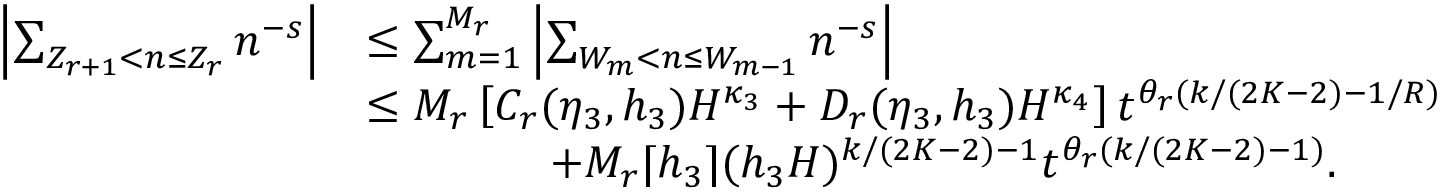Convert formula to latex. <formula><loc_0><loc_0><loc_500><loc_500>\begin{array} { r l } { \left | \sum _ { Z _ { r + 1 } < n \leq Z _ { r } } n ^ { - s } \right | } & { \leq \sum _ { m = 1 } ^ { M _ { r } } \left | \sum _ { W _ { m } < n \leq W _ { m - 1 } } n ^ { - s } \right | } \\ & { \leq M _ { r } \left [ C _ { r } ( \eta _ { 3 } , h _ { 3 } ) H ^ { \kappa _ { 3 } } + D _ { r } ( \eta _ { 3 } , h _ { 3 } ) H ^ { \kappa _ { 4 } } \right ] t ^ { \theta _ { r } ( k / ( 2 K - 2 ) - 1 / R ) } } \\ & { \quad + M _ { r } \lceil h _ { 3 } \rceil ( h _ { 3 } H ) ^ { k / ( 2 K - 2 ) - 1 } t ^ { \theta _ { r } ( k / ( 2 K - 2 ) - 1 ) } . } \end{array}</formula> 